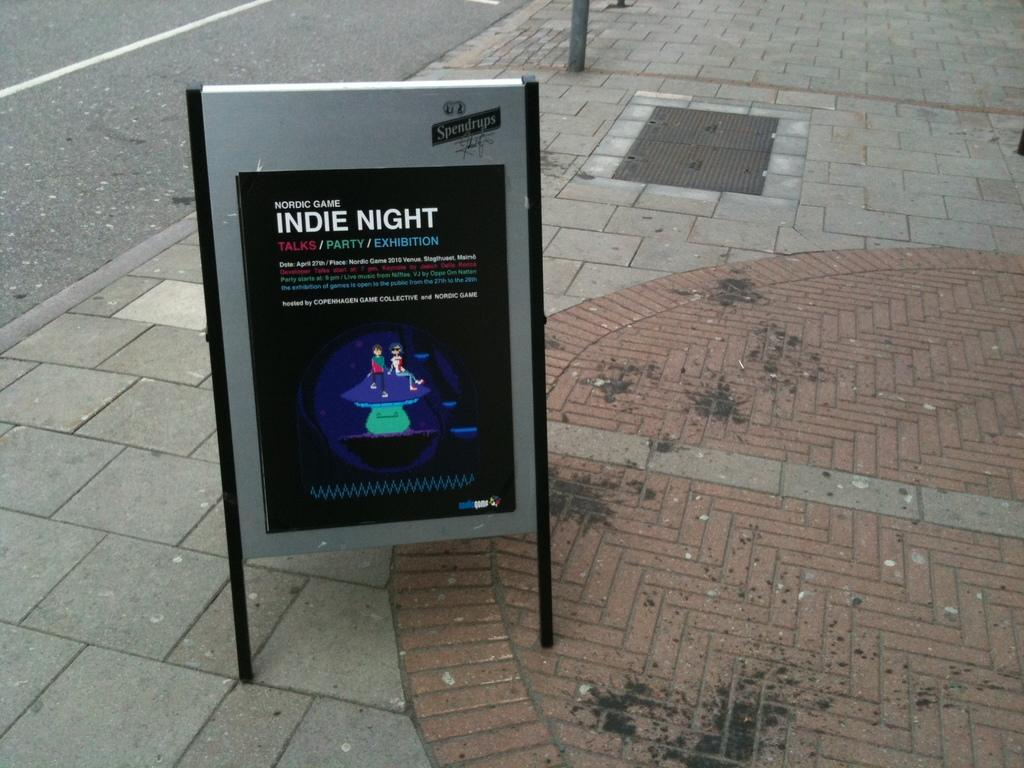<image>
Create a compact narrative representing the image presented. The Nordic Game Indie Night features Talks, Party, and Exhibition. 